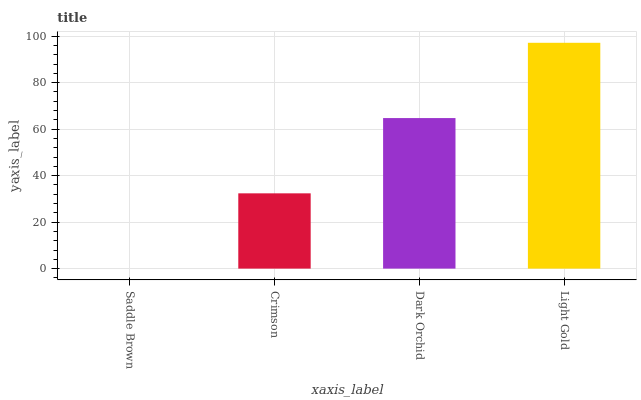Is Saddle Brown the minimum?
Answer yes or no. Yes. Is Light Gold the maximum?
Answer yes or no. Yes. Is Crimson the minimum?
Answer yes or no. No. Is Crimson the maximum?
Answer yes or no. No. Is Crimson greater than Saddle Brown?
Answer yes or no. Yes. Is Saddle Brown less than Crimson?
Answer yes or no. Yes. Is Saddle Brown greater than Crimson?
Answer yes or no. No. Is Crimson less than Saddle Brown?
Answer yes or no. No. Is Dark Orchid the high median?
Answer yes or no. Yes. Is Crimson the low median?
Answer yes or no. Yes. Is Light Gold the high median?
Answer yes or no. No. Is Saddle Brown the low median?
Answer yes or no. No. 